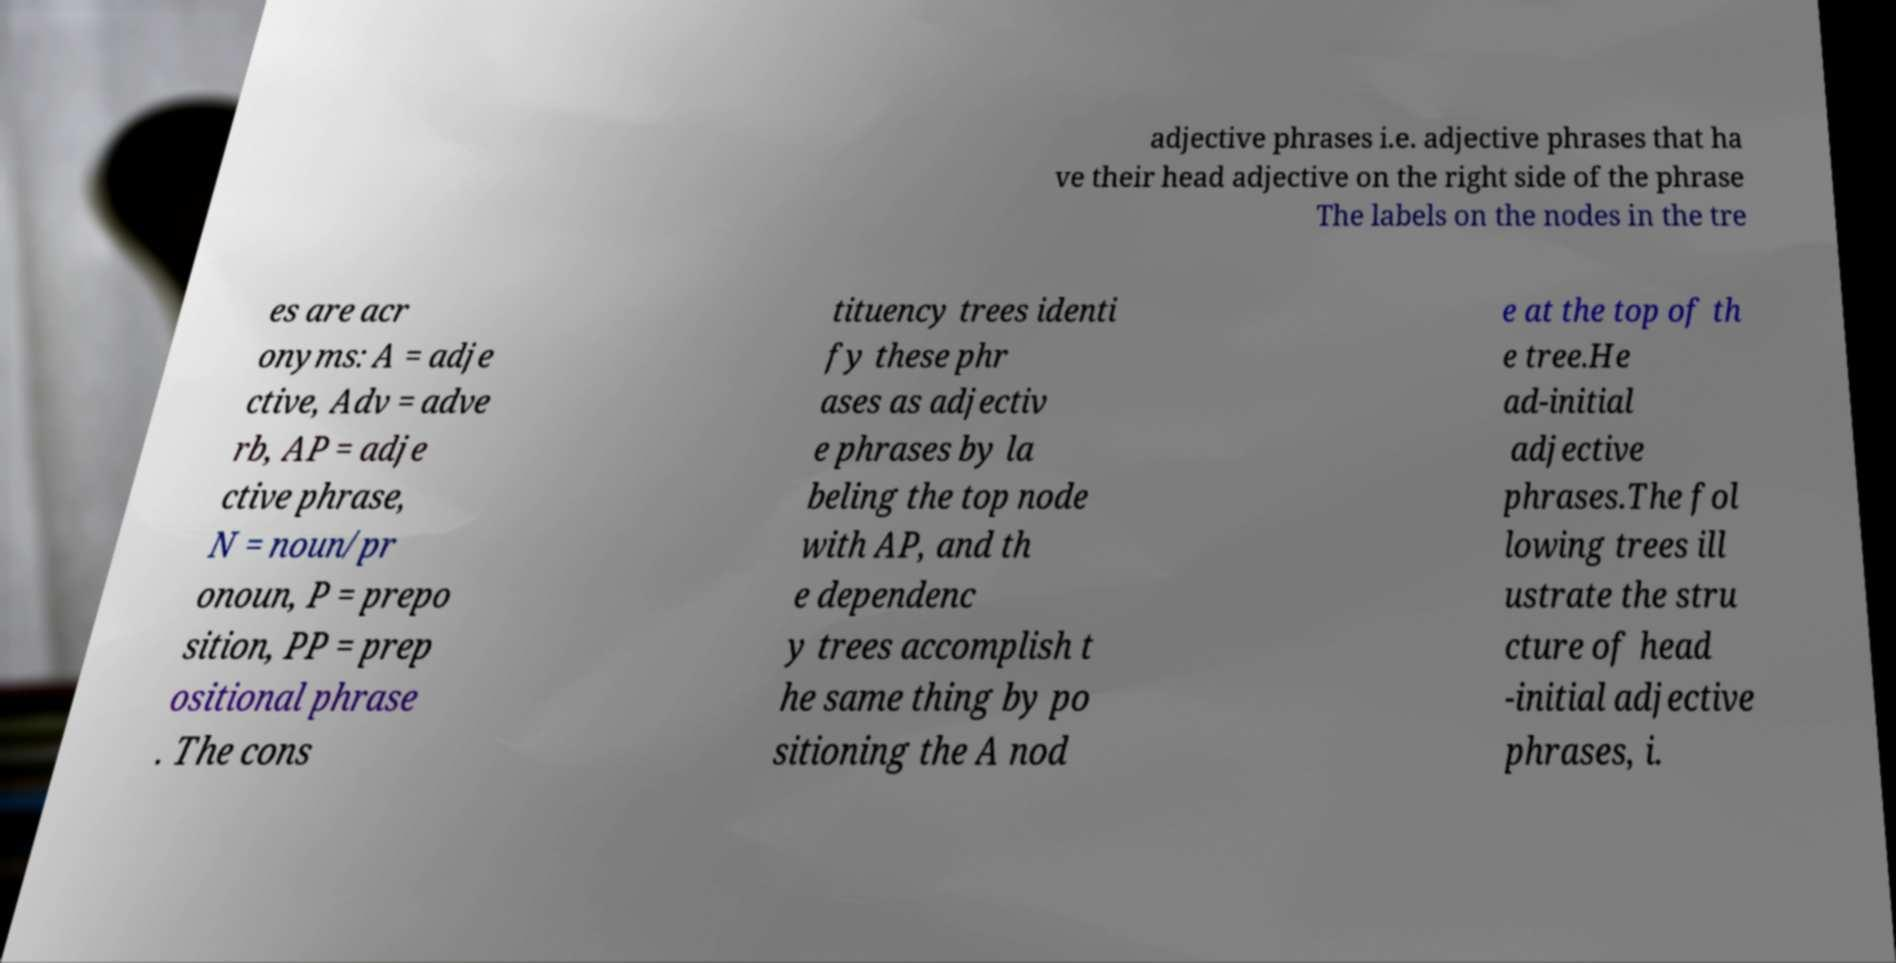Could you assist in decoding the text presented in this image and type it out clearly? adjective phrases i.e. adjective phrases that ha ve their head adjective on the right side of the phrase The labels on the nodes in the tre es are acr onyms: A = adje ctive, Adv = adve rb, AP = adje ctive phrase, N = noun/pr onoun, P = prepo sition, PP = prep ositional phrase . The cons tituency trees identi fy these phr ases as adjectiv e phrases by la beling the top node with AP, and th e dependenc y trees accomplish t he same thing by po sitioning the A nod e at the top of th e tree.He ad-initial adjective phrases.The fol lowing trees ill ustrate the stru cture of head -initial adjective phrases, i. 